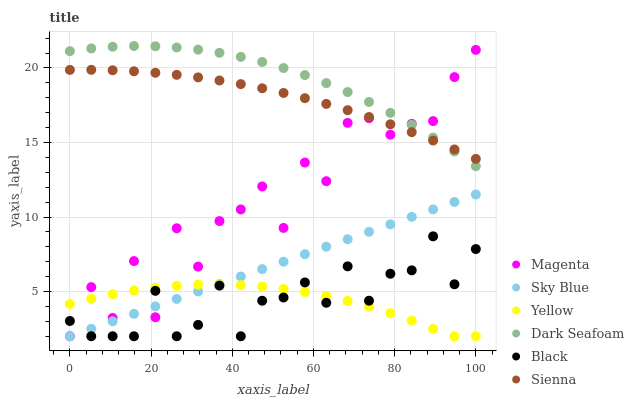Does Yellow have the minimum area under the curve?
Answer yes or no. Yes. Does Dark Seafoam have the maximum area under the curve?
Answer yes or no. Yes. Does Sienna have the minimum area under the curve?
Answer yes or no. No. Does Sienna have the maximum area under the curve?
Answer yes or no. No. Is Sky Blue the smoothest?
Answer yes or no. Yes. Is Magenta the roughest?
Answer yes or no. Yes. Is Sienna the smoothest?
Answer yes or no. No. Is Sienna the roughest?
Answer yes or no. No. Does Yellow have the lowest value?
Answer yes or no. Yes. Does Dark Seafoam have the lowest value?
Answer yes or no. No. Does Dark Seafoam have the highest value?
Answer yes or no. Yes. Does Sienna have the highest value?
Answer yes or no. No. Is Sky Blue less than Sienna?
Answer yes or no. Yes. Is Sienna greater than Black?
Answer yes or no. Yes. Does Magenta intersect Dark Seafoam?
Answer yes or no. Yes. Is Magenta less than Dark Seafoam?
Answer yes or no. No. Is Magenta greater than Dark Seafoam?
Answer yes or no. No. Does Sky Blue intersect Sienna?
Answer yes or no. No. 